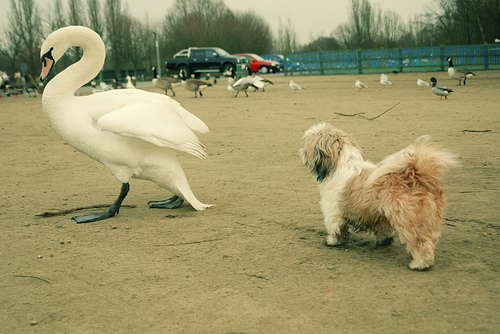<image>
Can you confirm if the duck is next to the dog? No. The duck is not positioned next to the dog. They are located in different areas of the scene. 